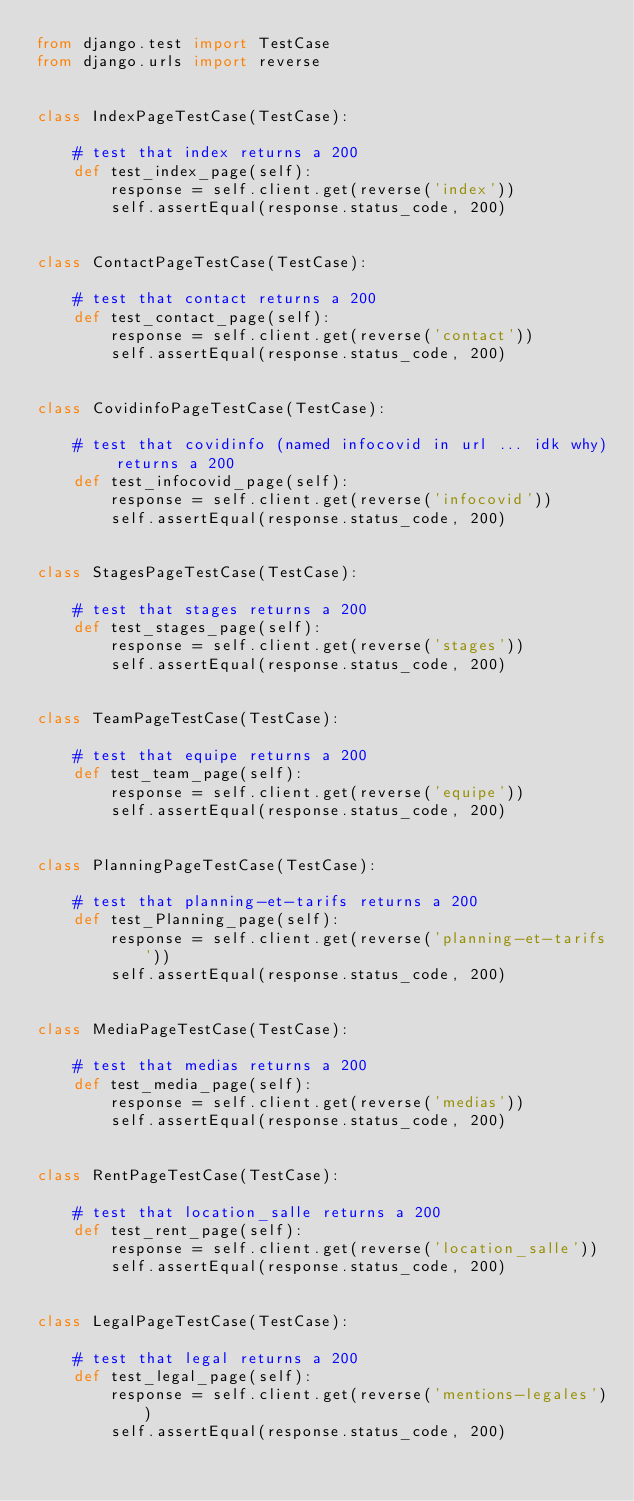Convert code to text. <code><loc_0><loc_0><loc_500><loc_500><_Python_>from django.test import TestCase
from django.urls import reverse


class IndexPageTestCase(TestCase):

    # test that index returns a 200
    def test_index_page(self):
        response = self.client.get(reverse('index'))
        self.assertEqual(response.status_code, 200)


class ContactPageTestCase(TestCase):

    # test that contact returns a 200
    def test_contact_page(self):
        response = self.client.get(reverse('contact'))
        self.assertEqual(response.status_code, 200)


class CovidinfoPageTestCase(TestCase):

    # test that covidinfo (named infocovid in url ... idk why) returns a 200
    def test_infocovid_page(self):
        response = self.client.get(reverse('infocovid'))
        self.assertEqual(response.status_code, 200)


class StagesPageTestCase(TestCase):

    # test that stages returns a 200
    def test_stages_page(self):
        response = self.client.get(reverse('stages'))
        self.assertEqual(response.status_code, 200)


class TeamPageTestCase(TestCase):

    # test that equipe returns a 200
    def test_team_page(self):
        response = self.client.get(reverse('equipe'))
        self.assertEqual(response.status_code, 200)


class PlanningPageTestCase(TestCase):

    # test that planning-et-tarifs returns a 200
    def test_Planning_page(self):
        response = self.client.get(reverse('planning-et-tarifs'))
        self.assertEqual(response.status_code, 200)


class MediaPageTestCase(TestCase):

    # test that medias returns a 200
    def test_media_page(self):
        response = self.client.get(reverse('medias'))
        self.assertEqual(response.status_code, 200)


class RentPageTestCase(TestCase):

    # test that location_salle returns a 200
    def test_rent_page(self):
        response = self.client.get(reverse('location_salle'))
        self.assertEqual(response.status_code, 200)


class LegalPageTestCase(TestCase):

    # test that legal returns a 200
    def test_legal_page(self):
        response = self.client.get(reverse('mentions-legales'))
        self.assertEqual(response.status_code, 200)
</code> 